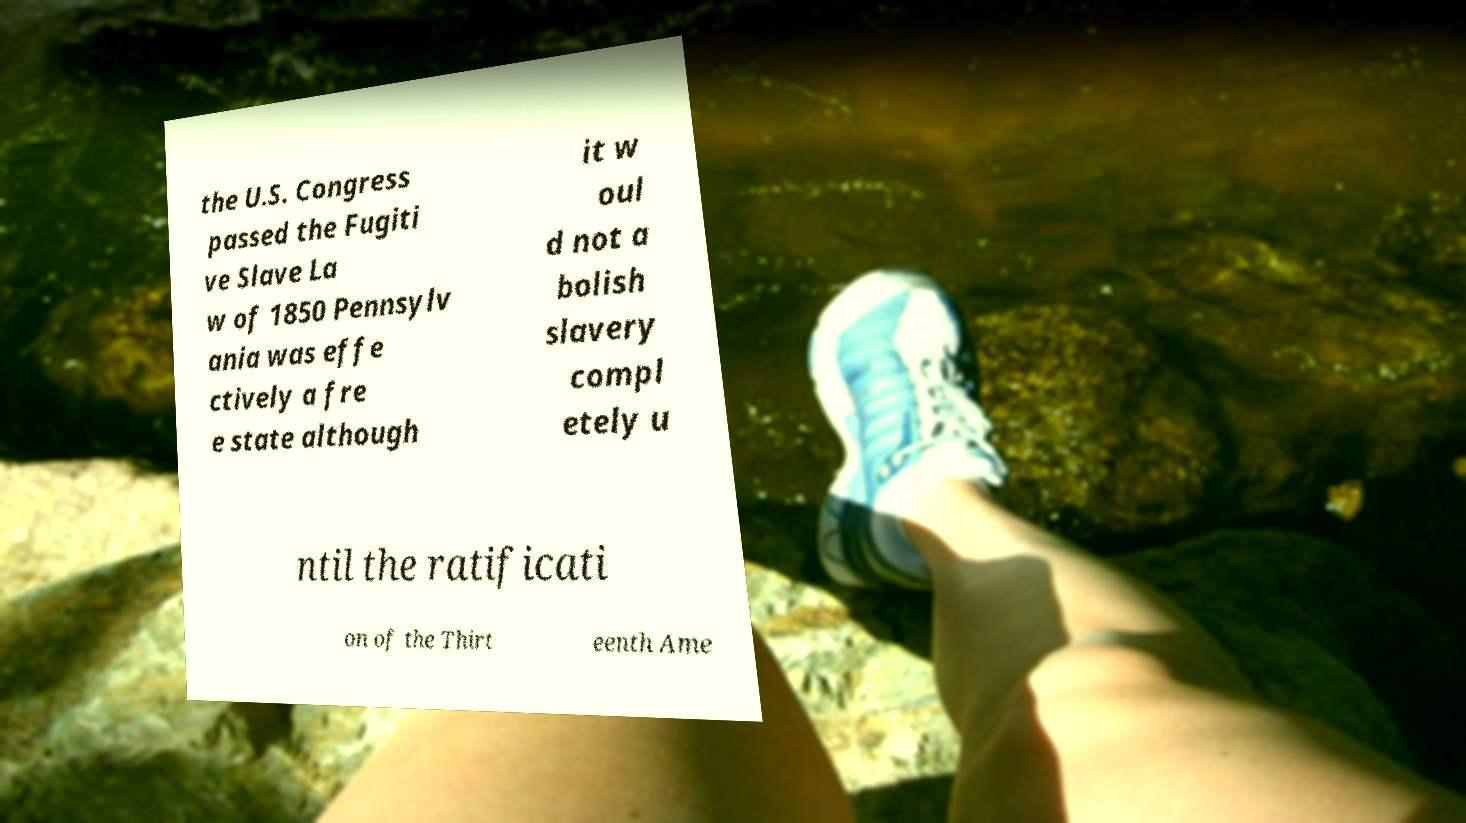Can you accurately transcribe the text from the provided image for me? the U.S. Congress passed the Fugiti ve Slave La w of 1850 Pennsylv ania was effe ctively a fre e state although it w oul d not a bolish slavery compl etely u ntil the ratificati on of the Thirt eenth Ame 